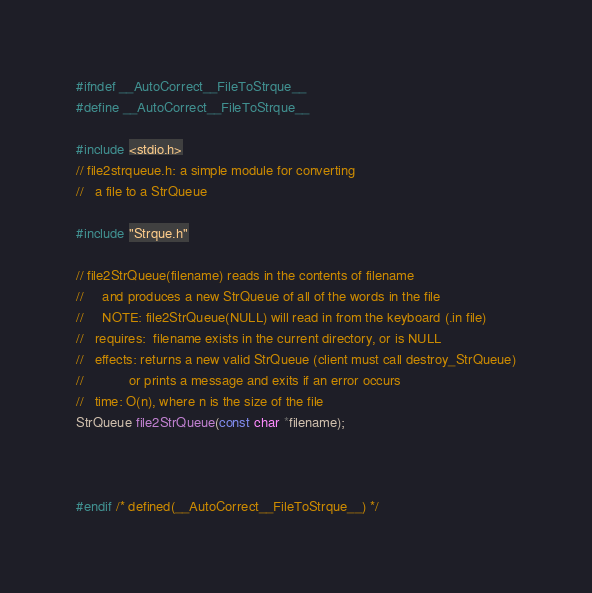<code> <loc_0><loc_0><loc_500><loc_500><_C_>
#ifndef __AutoCorrect__FileToStrque__
#define __AutoCorrect__FileToStrque__

#include <stdio.h>
// file2strqueue.h: a simple module for converting
//   a file to a StrQueue

#include "Strque.h"

// file2StrQueue(filename) reads in the contents of filename
//     and produces a new StrQueue of all of the words in the file
//     NOTE: file2StrQueue(NULL) will read in from the keyboard (.in file)
//   requires:  filename exists in the current directory, or is NULL
//   effects: returns a new valid StrQueue (client must call destroy_StrQueue)
//            or prints a message and exits if an error occurs
//   time: O(n), where n is the size of the file
StrQueue file2StrQueue(const char *filename);



#endif /* defined(__AutoCorrect__FileToStrque__) */
</code> 